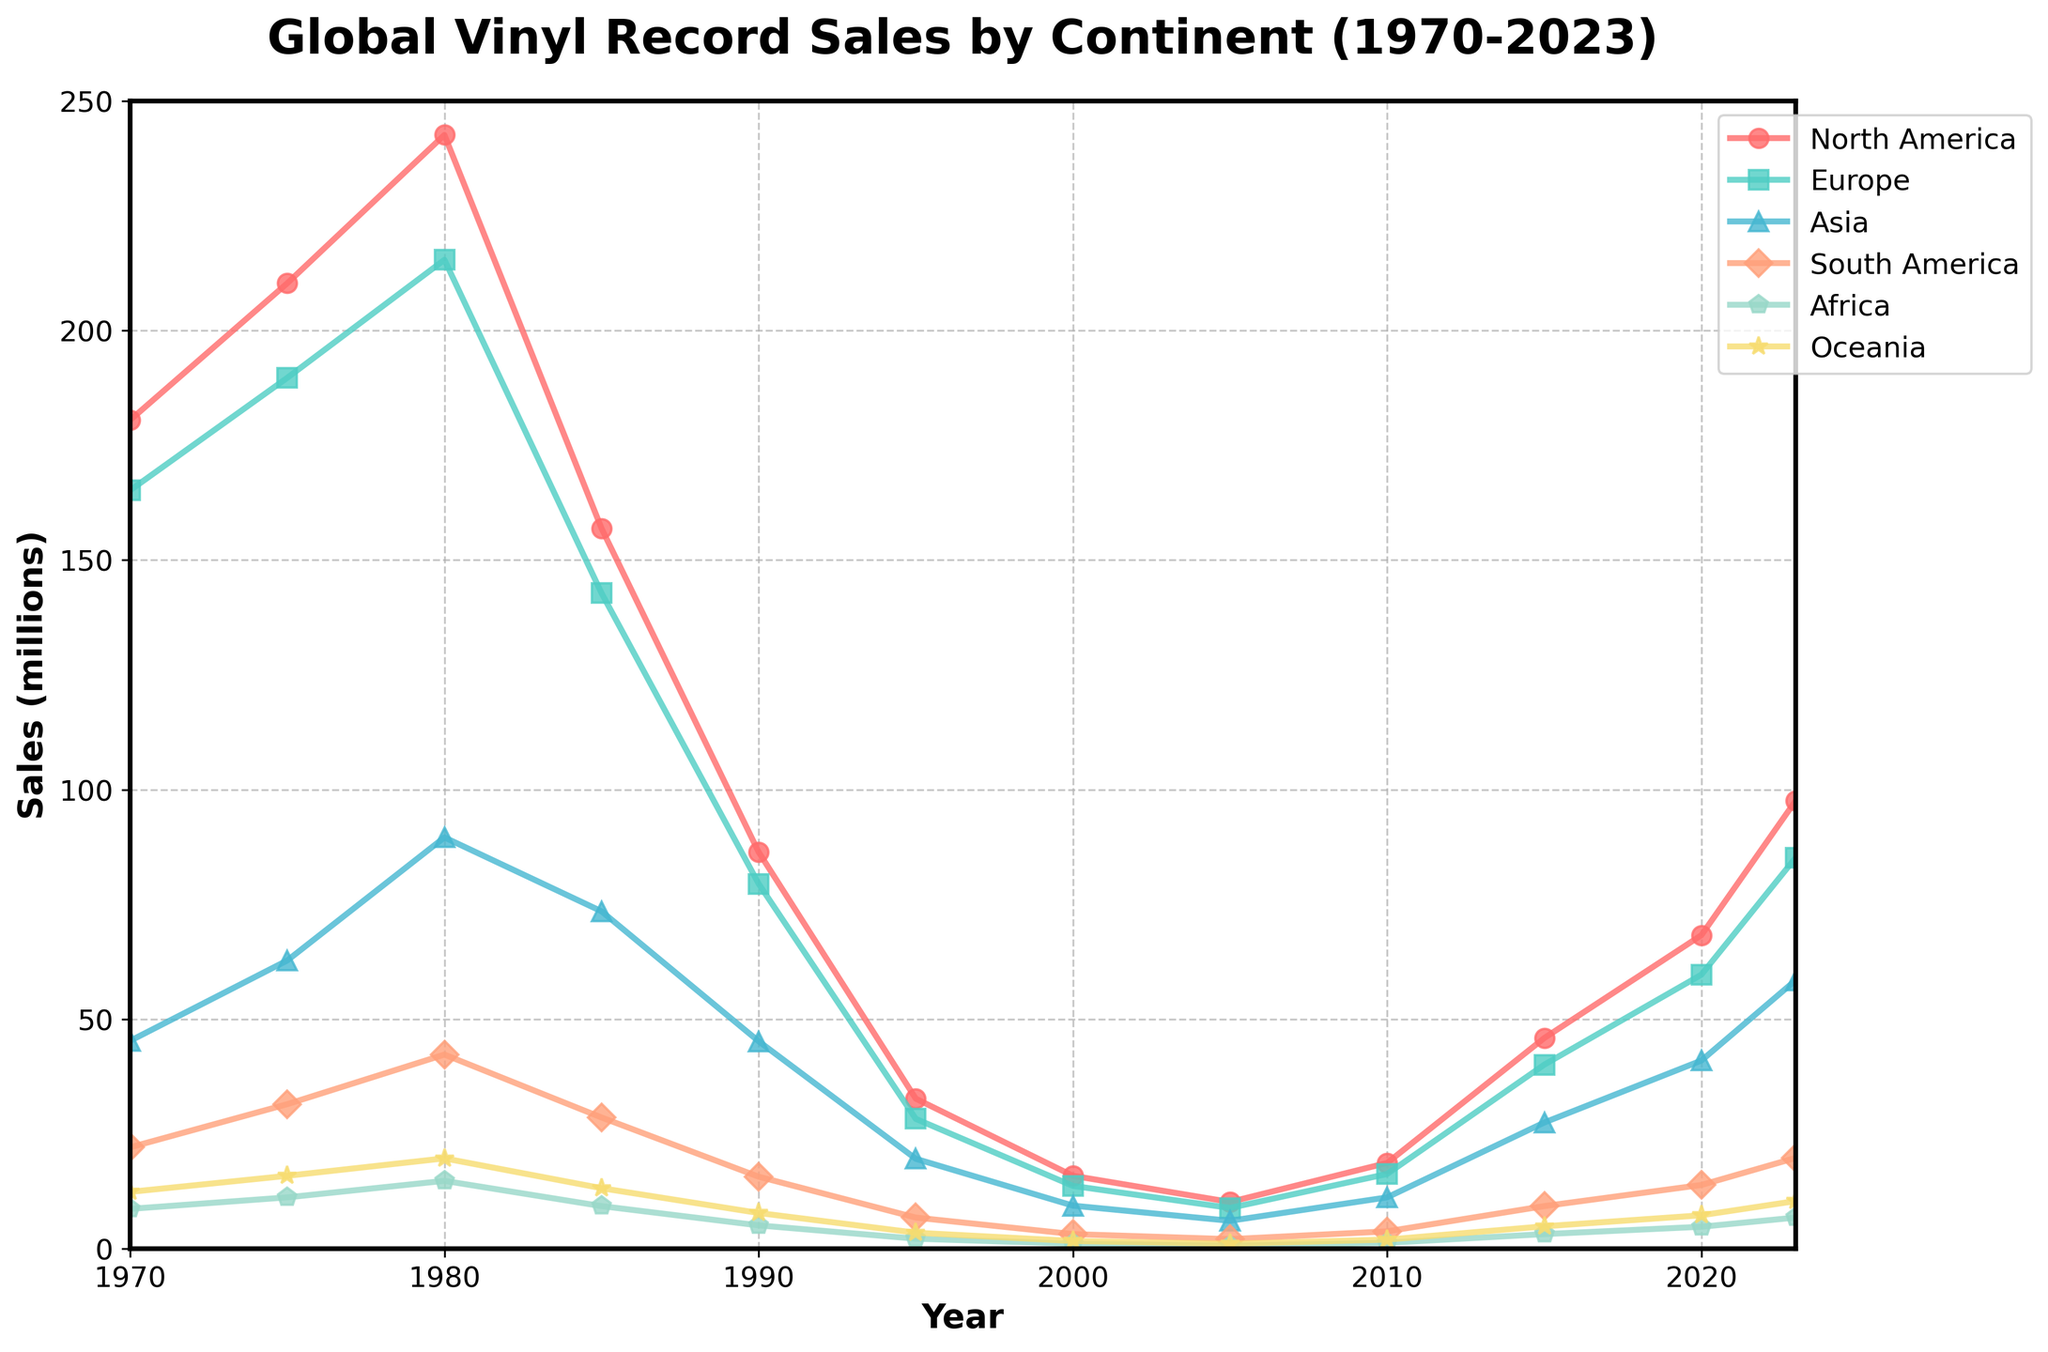What trend is observed in the sales of vinyl records in North America between 1970 and 2000? The trend shows an initial increase in sales from 1970 to 1980, peaking at 242.6 million, followed by a decline from 1980 to 2000, reaching 15.9 million.
Answer: Initial increase, then decline Which continent had the highest sales of vinyl records in 1980? By looking at the data for 1980, North America had the highest sales with 242.6 million.
Answer: North America In which year did European vinyl record sales start increasing after a consistent decline and by how much did they increase by 2023 from that year? European sales increased after 2005. In 2005, the sales were 8.9 million, and by 2023, they increased to 85.2 million. Thus, the increase was 85.2 - 8.9 = 76.3 million.
Answer: After 2005, increased by 76.3 million Which continent shows the largest relative increase in vinyl sales from 2005 to 2023? To determine the largest relative increase, we need to compare the percentage increase for each continent. The relative increase for Oceania is the highest: from 1.1 million in 2005 to 10.4 million in 2023, which is an increase of (10.4 - 1.1) / 1.1 * 100 = 845.5%.
Answer: Oceania Between which two consecutive years did South America experience the largest growth in vinyl sales? The largest growth occurred between 2010 (3.8 million) and 2015 (9.3 million), which is a growth of 9.3 - 3.8 = 5.5 million.
Answer: 2010 and 2015 Compare the vinyl sales in Asia and Europe in 1990, and which continent had higher sales? By how much? In 1990, Asia had 45.2 million and Europe had 79.5 million, so Europe had higher sales. The difference is 79.5 - 45.2 = 34.3 million.
Answer: Europe, by 34.3 million Which visual element (color/marker) represents Oceania in the chart, and how can you identify it? Oceania is represented by a combination of a dark yellow color and an asterisk-shaped marker. This can be identified by the color and marker type used in the legend corresponding to Oceania.
Answer: Dark yellow, asterisk What can you infer about the trend of vinyl sales in Africa from 2000 to 2023? The sales of vinyl records in Africa demonstrate a steady increase from 1.1 million in 2000 to 6.8 million in 2023.
Answer: Steady increase What is the sum of vinyl sales in 2023 for Europe and North America? The sales for Europe in 2023 is 85.2 million, and for North America, it is 97.6 million. Summing them, 85.2 + 97.6 = 182.8 million.
Answer: 182.8 million 